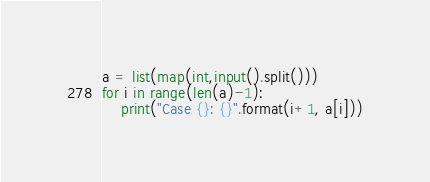<code> <loc_0><loc_0><loc_500><loc_500><_Python_>a = list(map(int,input().split()))
for i in range(len(a)-1):
    print("Case {}: {}".format(i+1, a[i]))</code> 